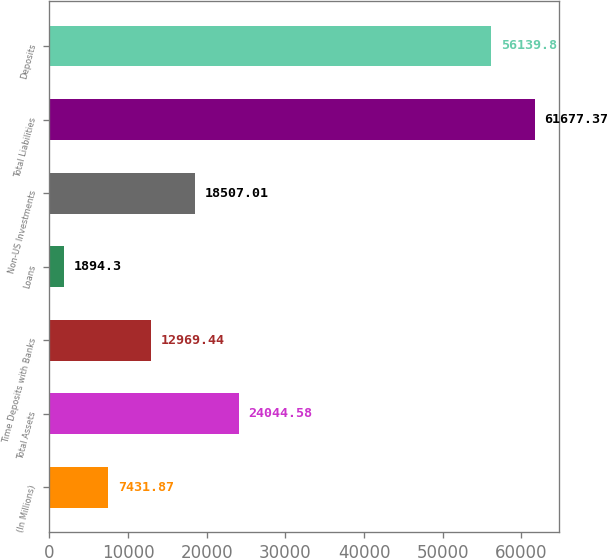Convert chart. <chart><loc_0><loc_0><loc_500><loc_500><bar_chart><fcel>(In Millions)<fcel>Total Assets<fcel>Time Deposits with Banks<fcel>Loans<fcel>Non-US Investments<fcel>Total Liabilities<fcel>Deposits<nl><fcel>7431.87<fcel>24044.6<fcel>12969.4<fcel>1894.3<fcel>18507<fcel>61677.4<fcel>56139.8<nl></chart> 